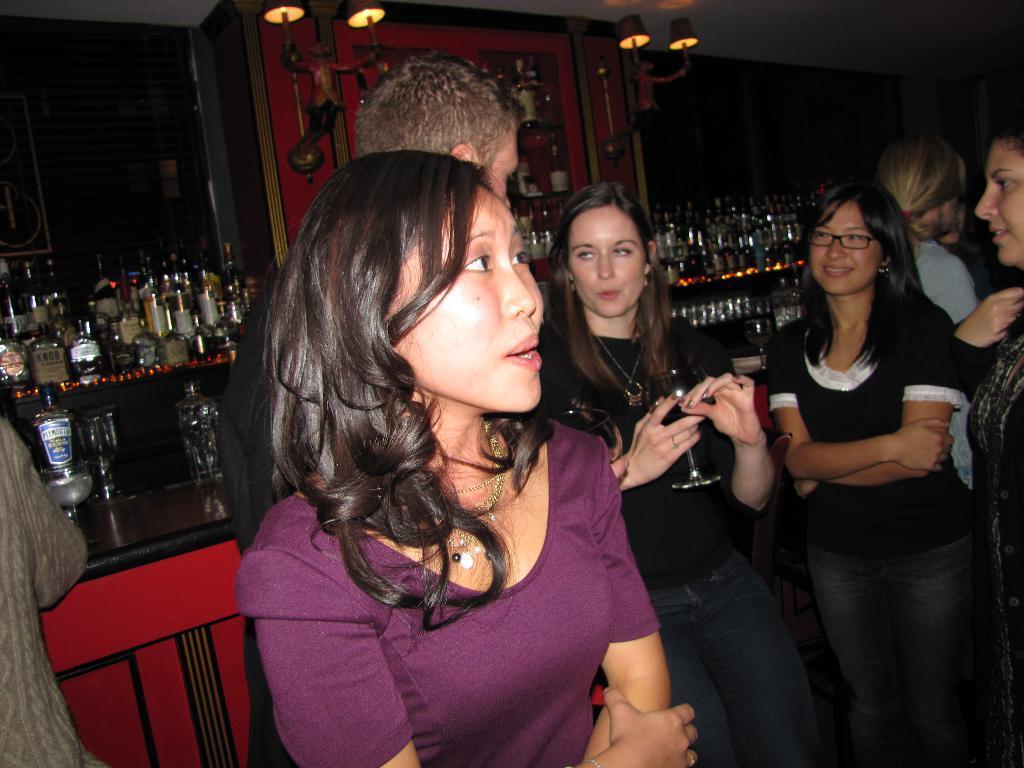How would you summarize this image in a sentence or two? In this image I can see the group of people with different color dresses. In the background I can see many wine bottles and glasses. I can also see the lights in the top. 